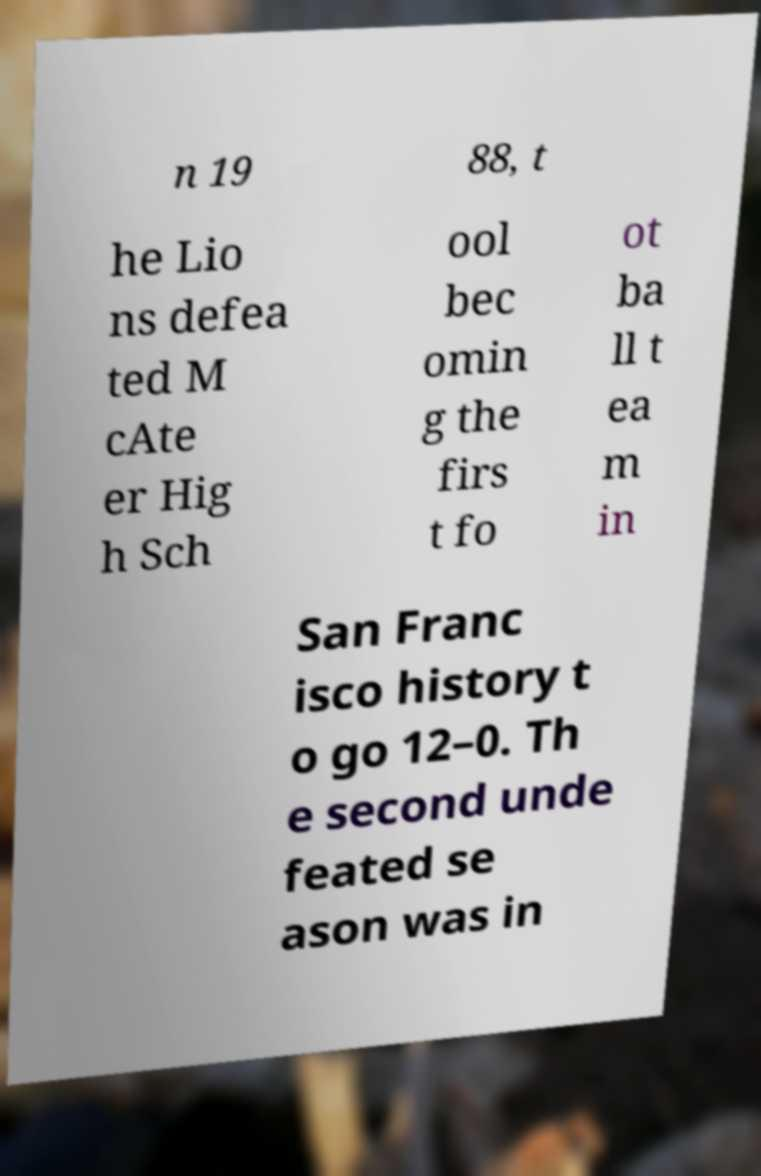There's text embedded in this image that I need extracted. Can you transcribe it verbatim? n 19 88, t he Lio ns defea ted M cAte er Hig h Sch ool bec omin g the firs t fo ot ba ll t ea m in San Franc isco history t o go 12–0. Th e second unde feated se ason was in 